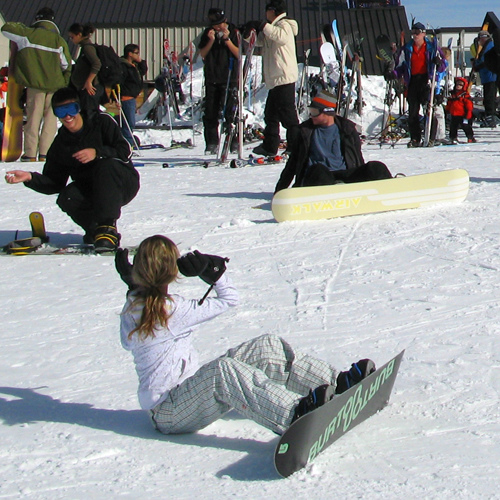Identify the text contained in this image. AUATO 